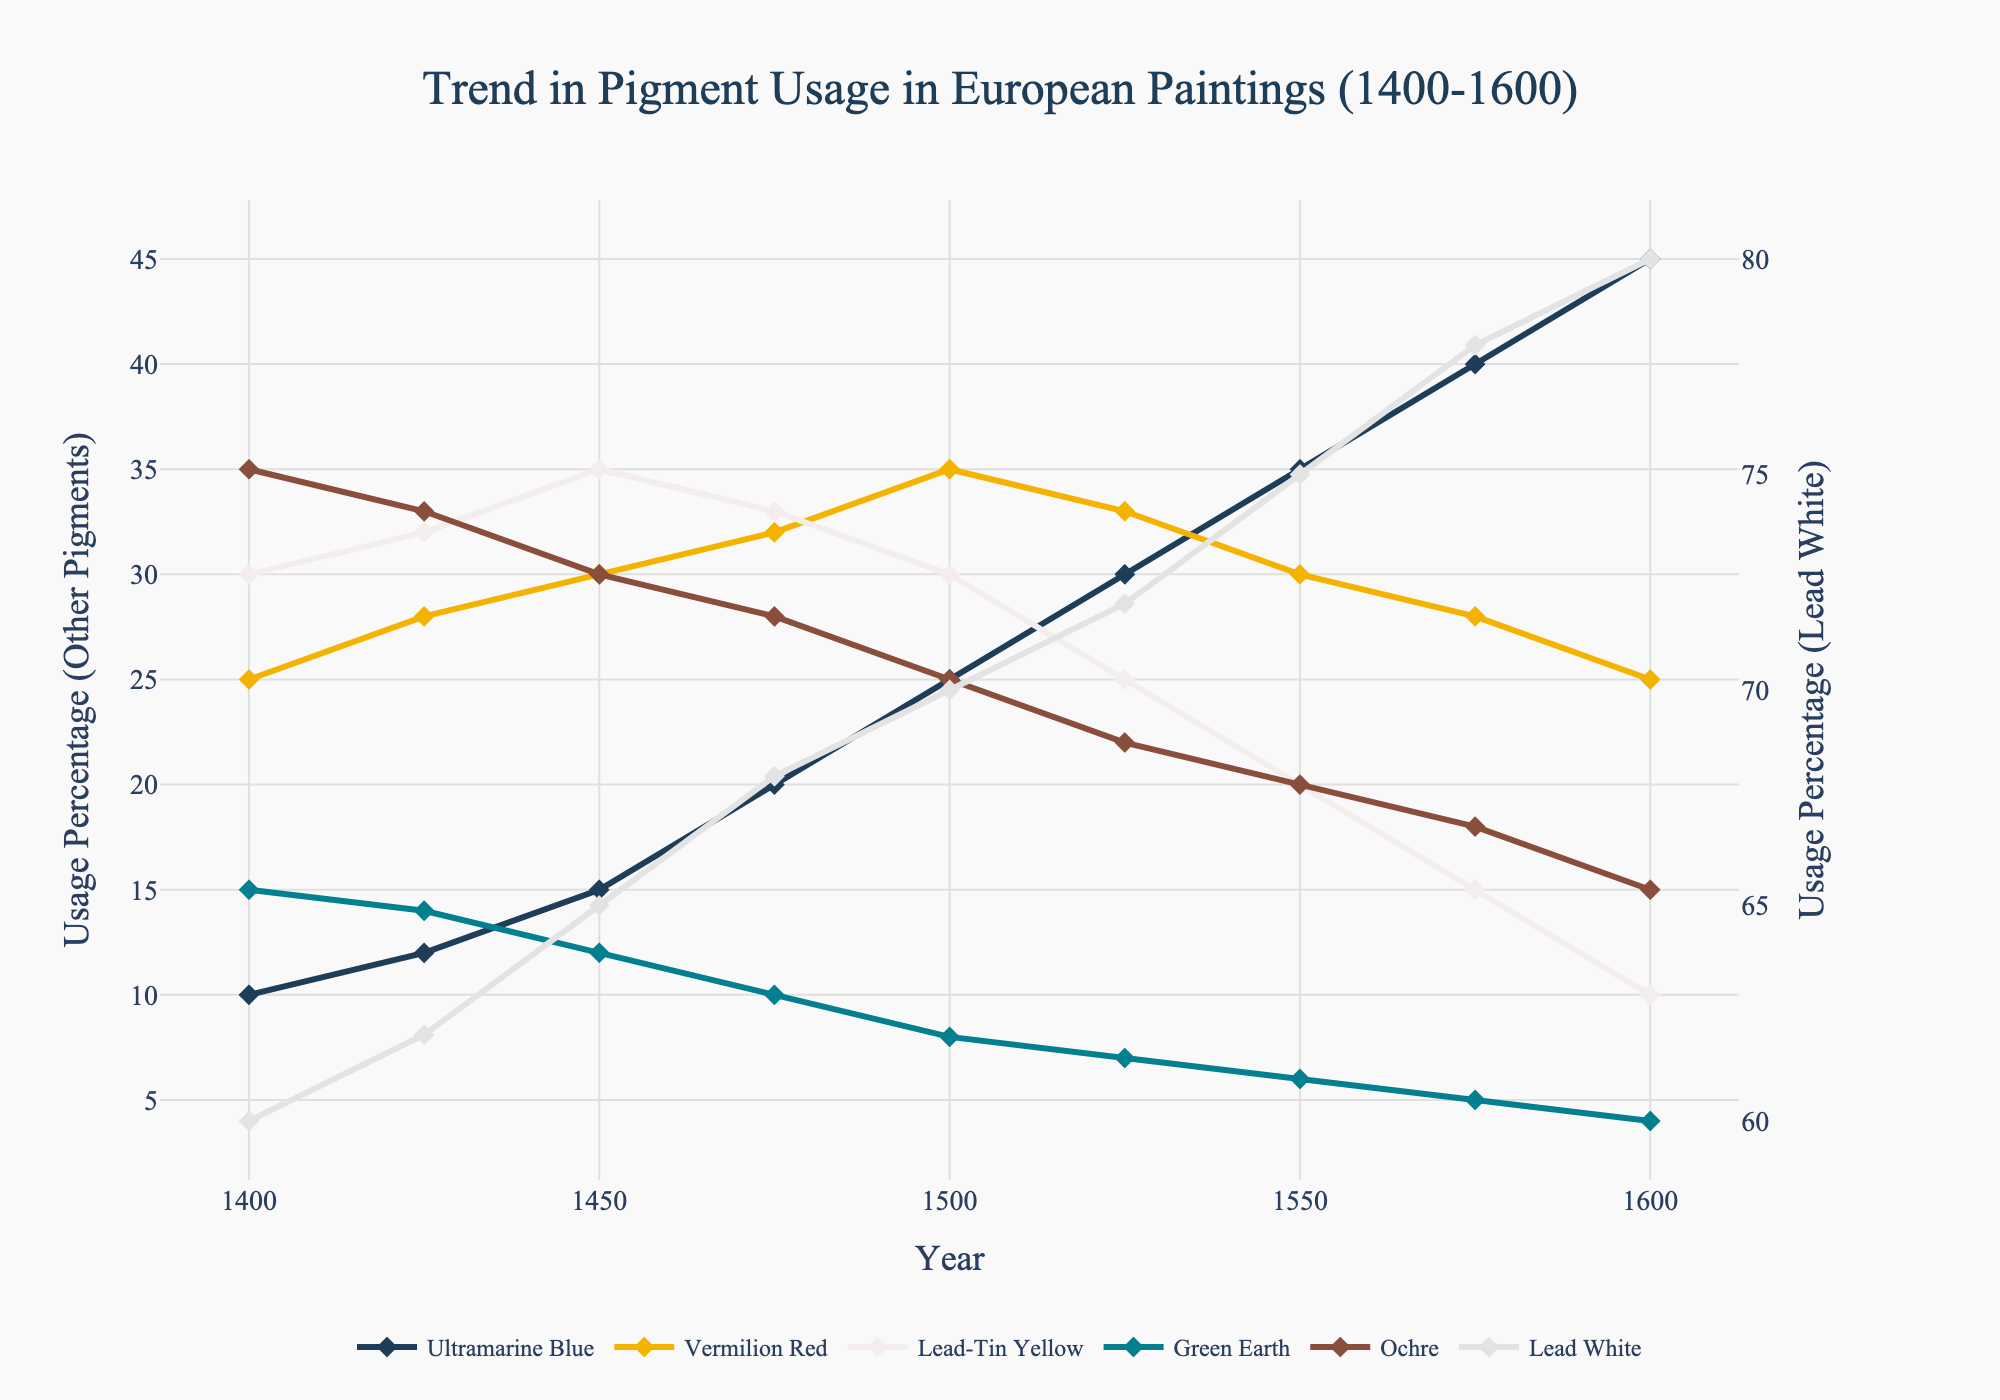What year did Ultramarine Blue reach its highest usage? By looking at the plot, find the year where Ultramarine Blue's line graph has the highest point. The highest point is around 1600.
Answer: 1600 Which pigment showed a consistent increase in usage over the 200-year period? Look for the pigment whose line graph always trends upward from 1400 to 1600. Lead White’s usage consistently increases from 60% to 80%.
Answer: Lead White In 1500, which pigment had the second highest usage? Inspect the value of each pigment in 1500 and identify the one with the second highest percentage. Lead White had the highest (70%), and Ochre had the second highest (25%).
Answer: Ochre How many pigments showed a decrease in usage between 1450 and 1600? Compare the values of each pigment in 1450 and 1600 and count how many show a lower value in 1600 compared to 1450. Vermilion Red, Lead-Tin Yellow, Green Earth, and Ochre decreased.
Answer: 4 Between which two years did Vermilion Red show the largest decline in usage? Locate the points for Vermilion Red and determine the largest drop between any two consecutive points. The largest decline is between 1550 and 1600, from 30 to 25.
Answer: 1550-1600 What is the total difference in Lead White usage from 1400 to 1600? Subtract the usage of Lead White in 1400 from its usage in 1600. The difference is 80% - 60% = 20%.
Answer: 20% How did the usage trend for Green Earth differ from that of Ultramarine Blue? Compare the general direction of the lines for Green Earth and Ultramarine Blue. Green Earth consistently decreased, while Ultramarine Blue consistently increased.
Answer: Green Earth decreased, Ultramarine Blue increased Which year saw an equal usage percentage of Ultramarine Blue and Lead-Tin Yellow? Find the year where the values of Ultramarine Blue and Lead-Tin Yellow intersect. Both are 30% in the year 1500.
Answer: 1500 In 1575, which pigment had the smallest usage percentage? Check the values of all pigments in 1575 and identify the one with the lowest percentage. Green Earth had the smallest usage at 5%.
Answer: Green Earth In what year did Lead-Tin Yellow's usage drop below 20% for the first time? Identify the first year where Lead-Tin Yellow's usage is below 20%. It first drops below 20% in 1550 at 20%.
Answer: 1550 